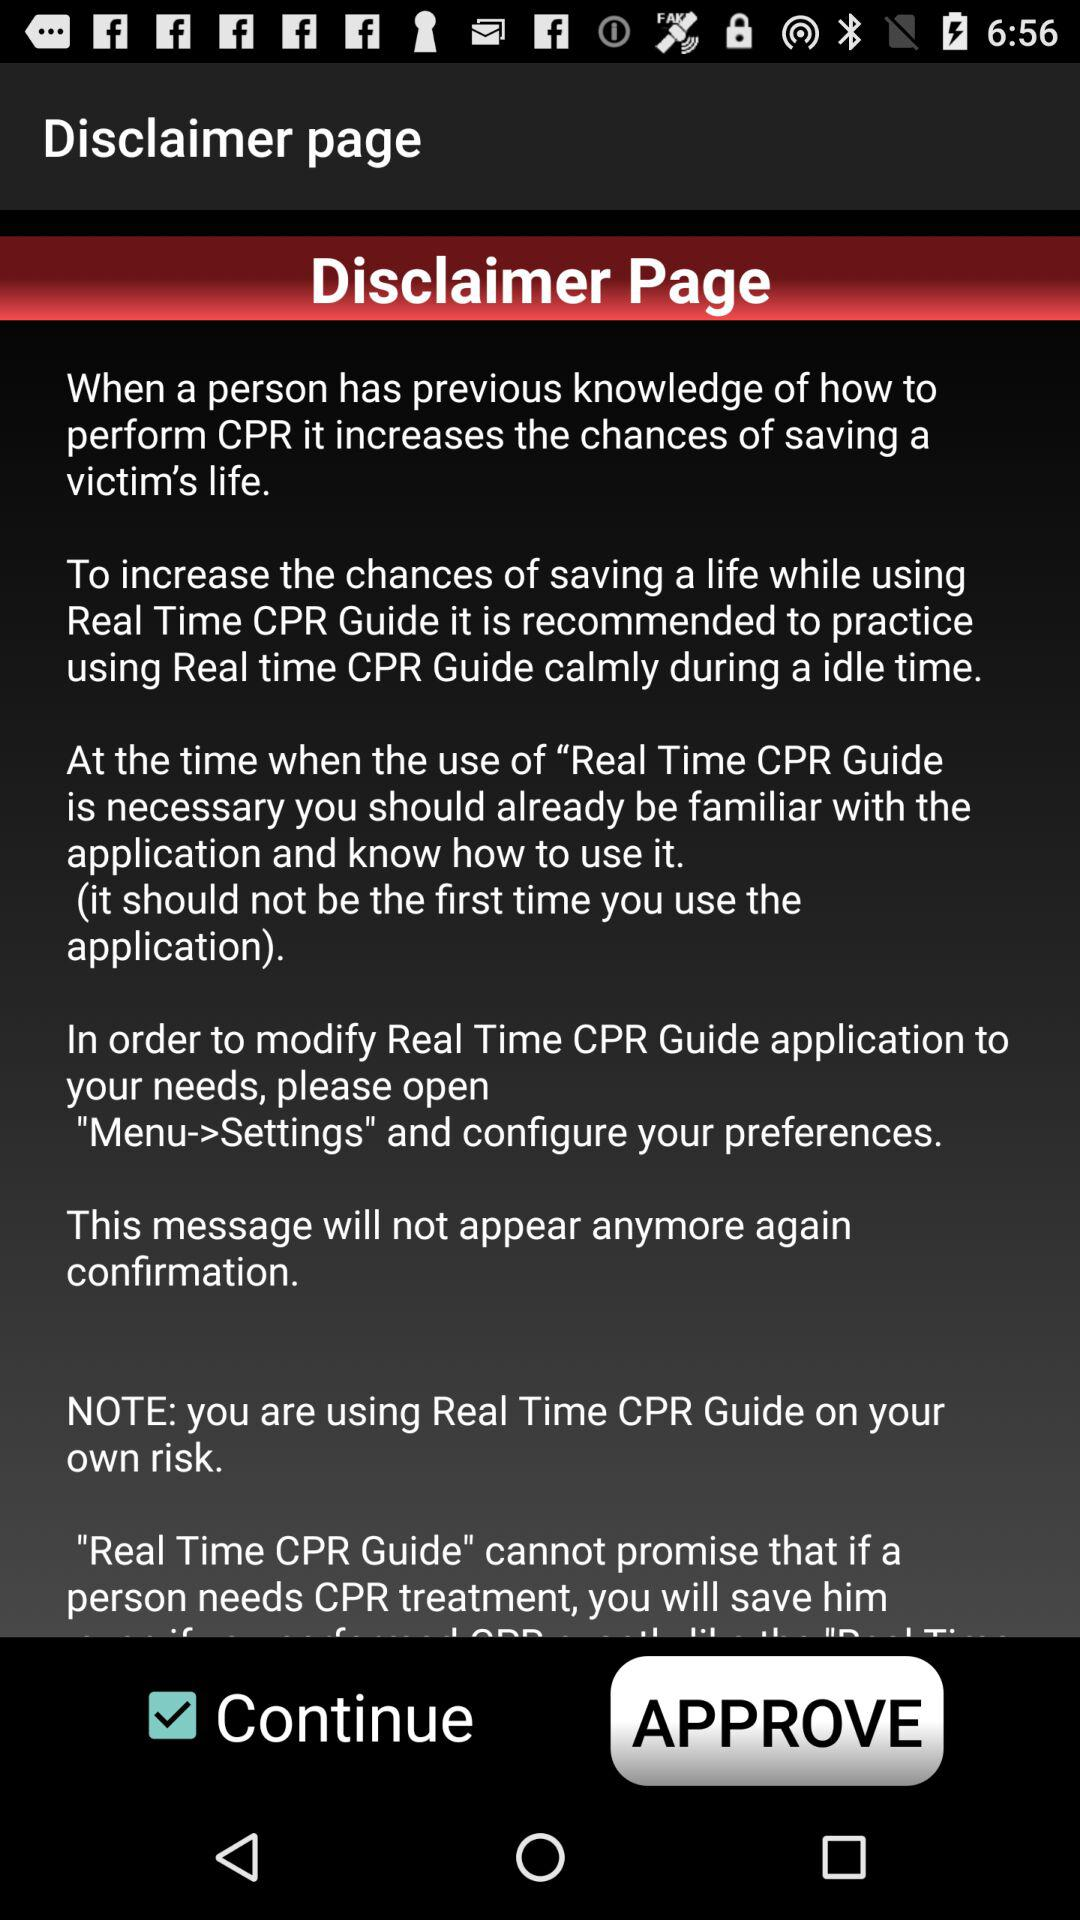What is the status of "Continue"? The status of "Continue" is "on". 